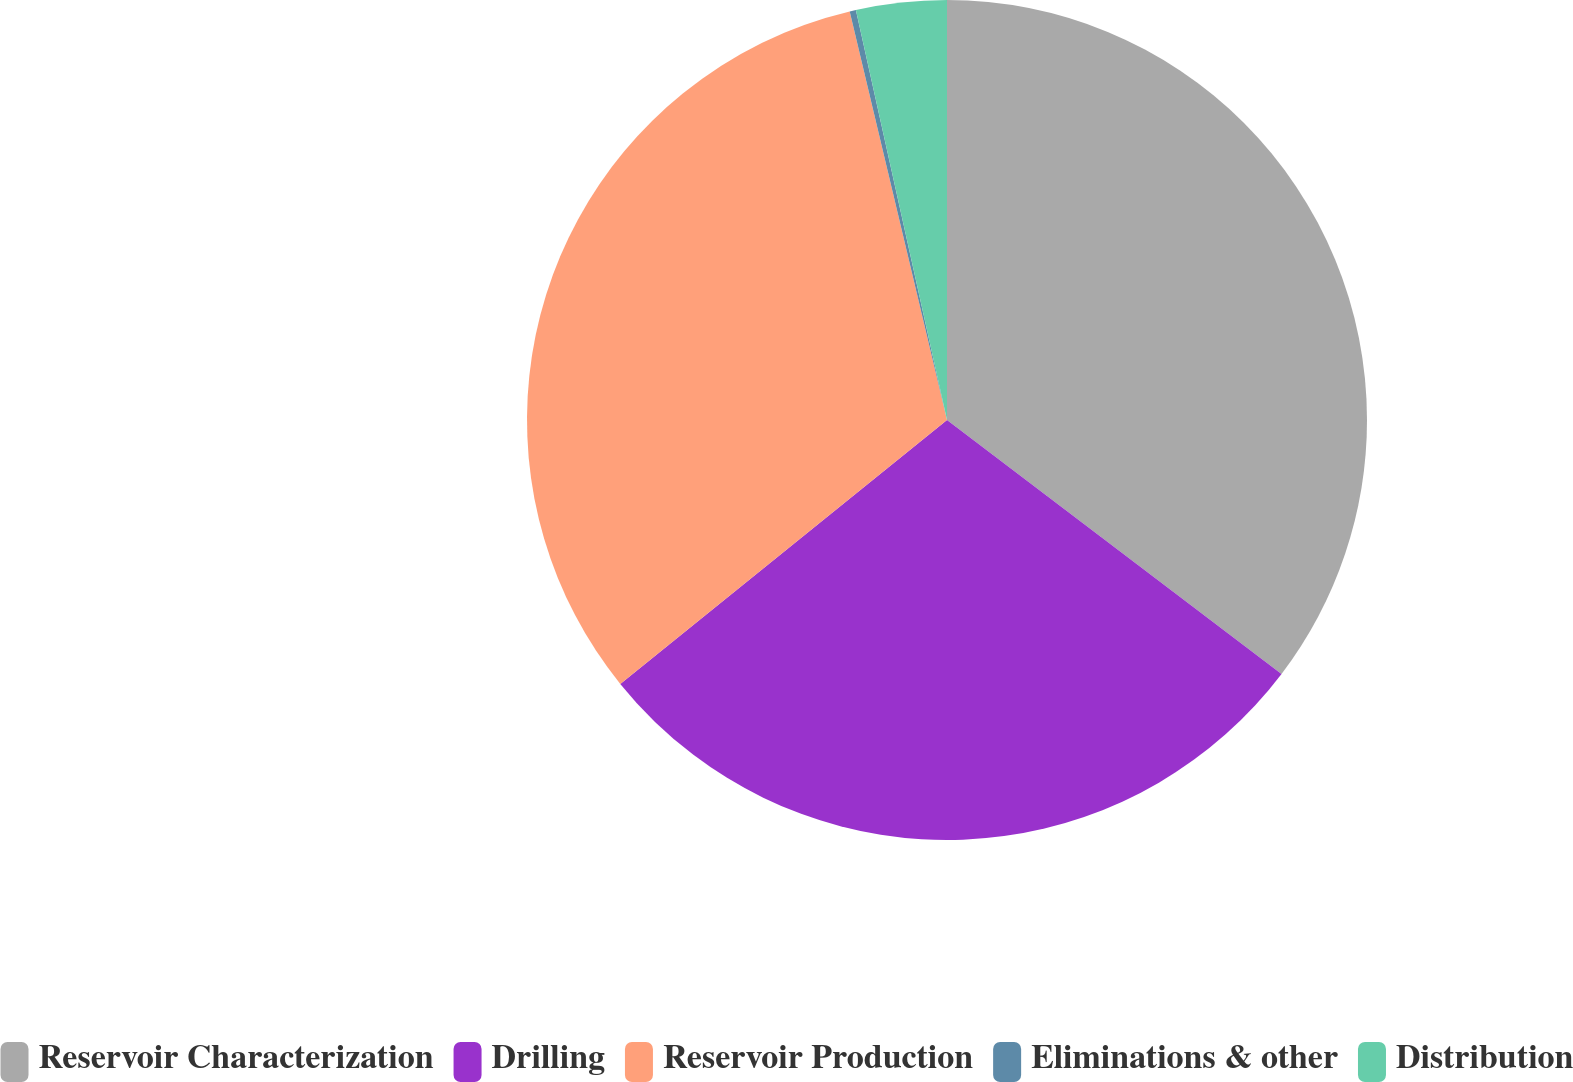Convert chart to OTSL. <chart><loc_0><loc_0><loc_500><loc_500><pie_chart><fcel>Reservoir Characterization<fcel>Drilling<fcel>Reservoir Production<fcel>Eliminations & other<fcel>Distribution<nl><fcel>35.33%<fcel>28.85%<fcel>32.09%<fcel>0.24%<fcel>3.48%<nl></chart> 